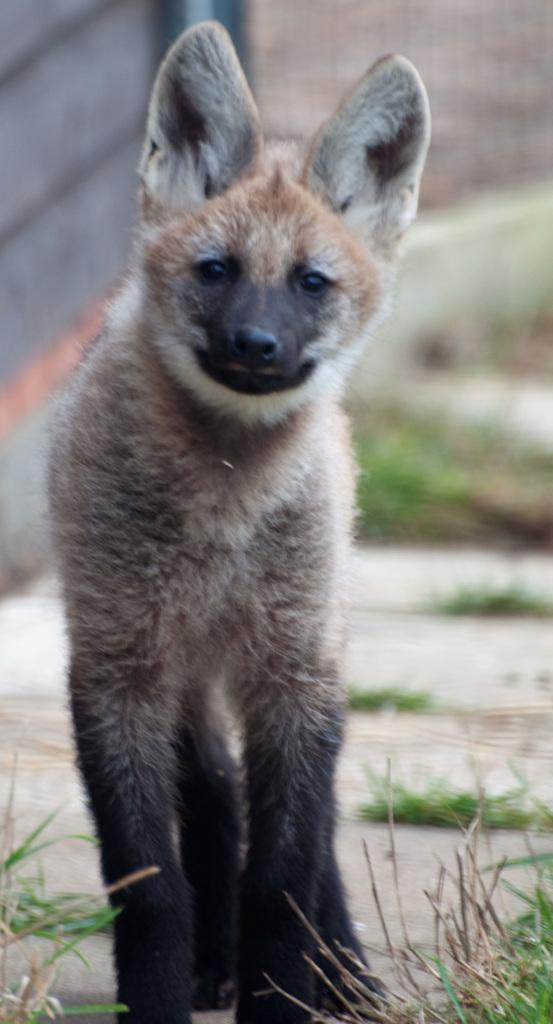In one or two sentences, can you explain what this image depicts? In this image, we can see hyena standing on the path. At the bottom of the image, we can see grass. In the background, there is a blur view. Here we can see mesh, wall and grass. 